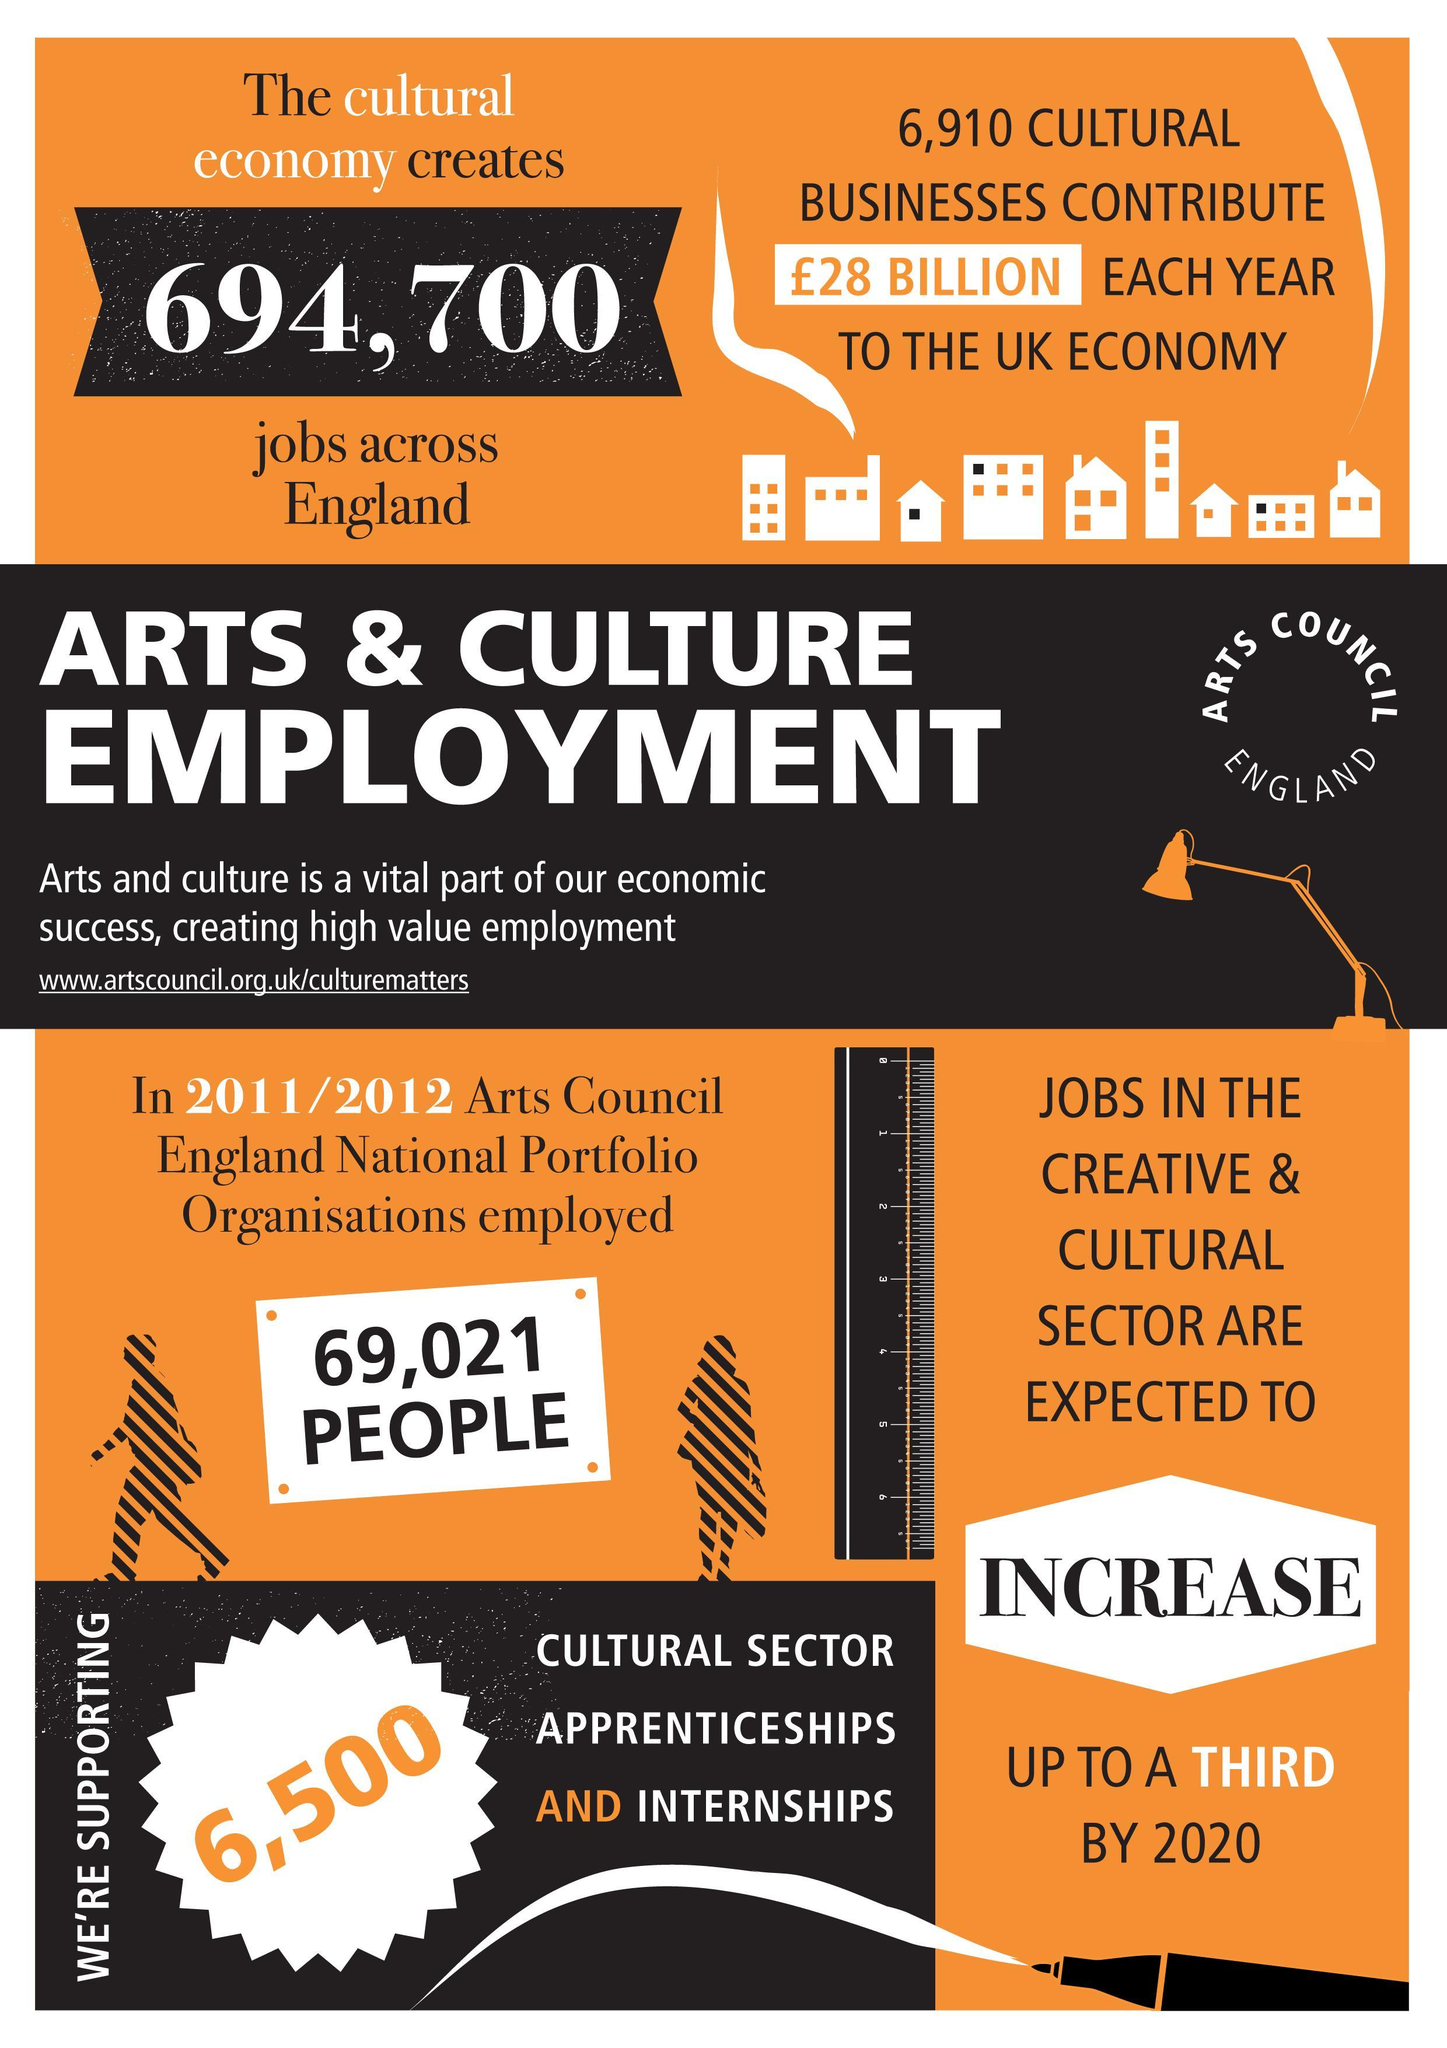How many jobs does cultural economy creates in England
Answer the question with a short phrase. 694,700 How many cultural sector apprenticeships and internships 6,500 Will the jobs in creative and cultural sector increase or decrease? increase 